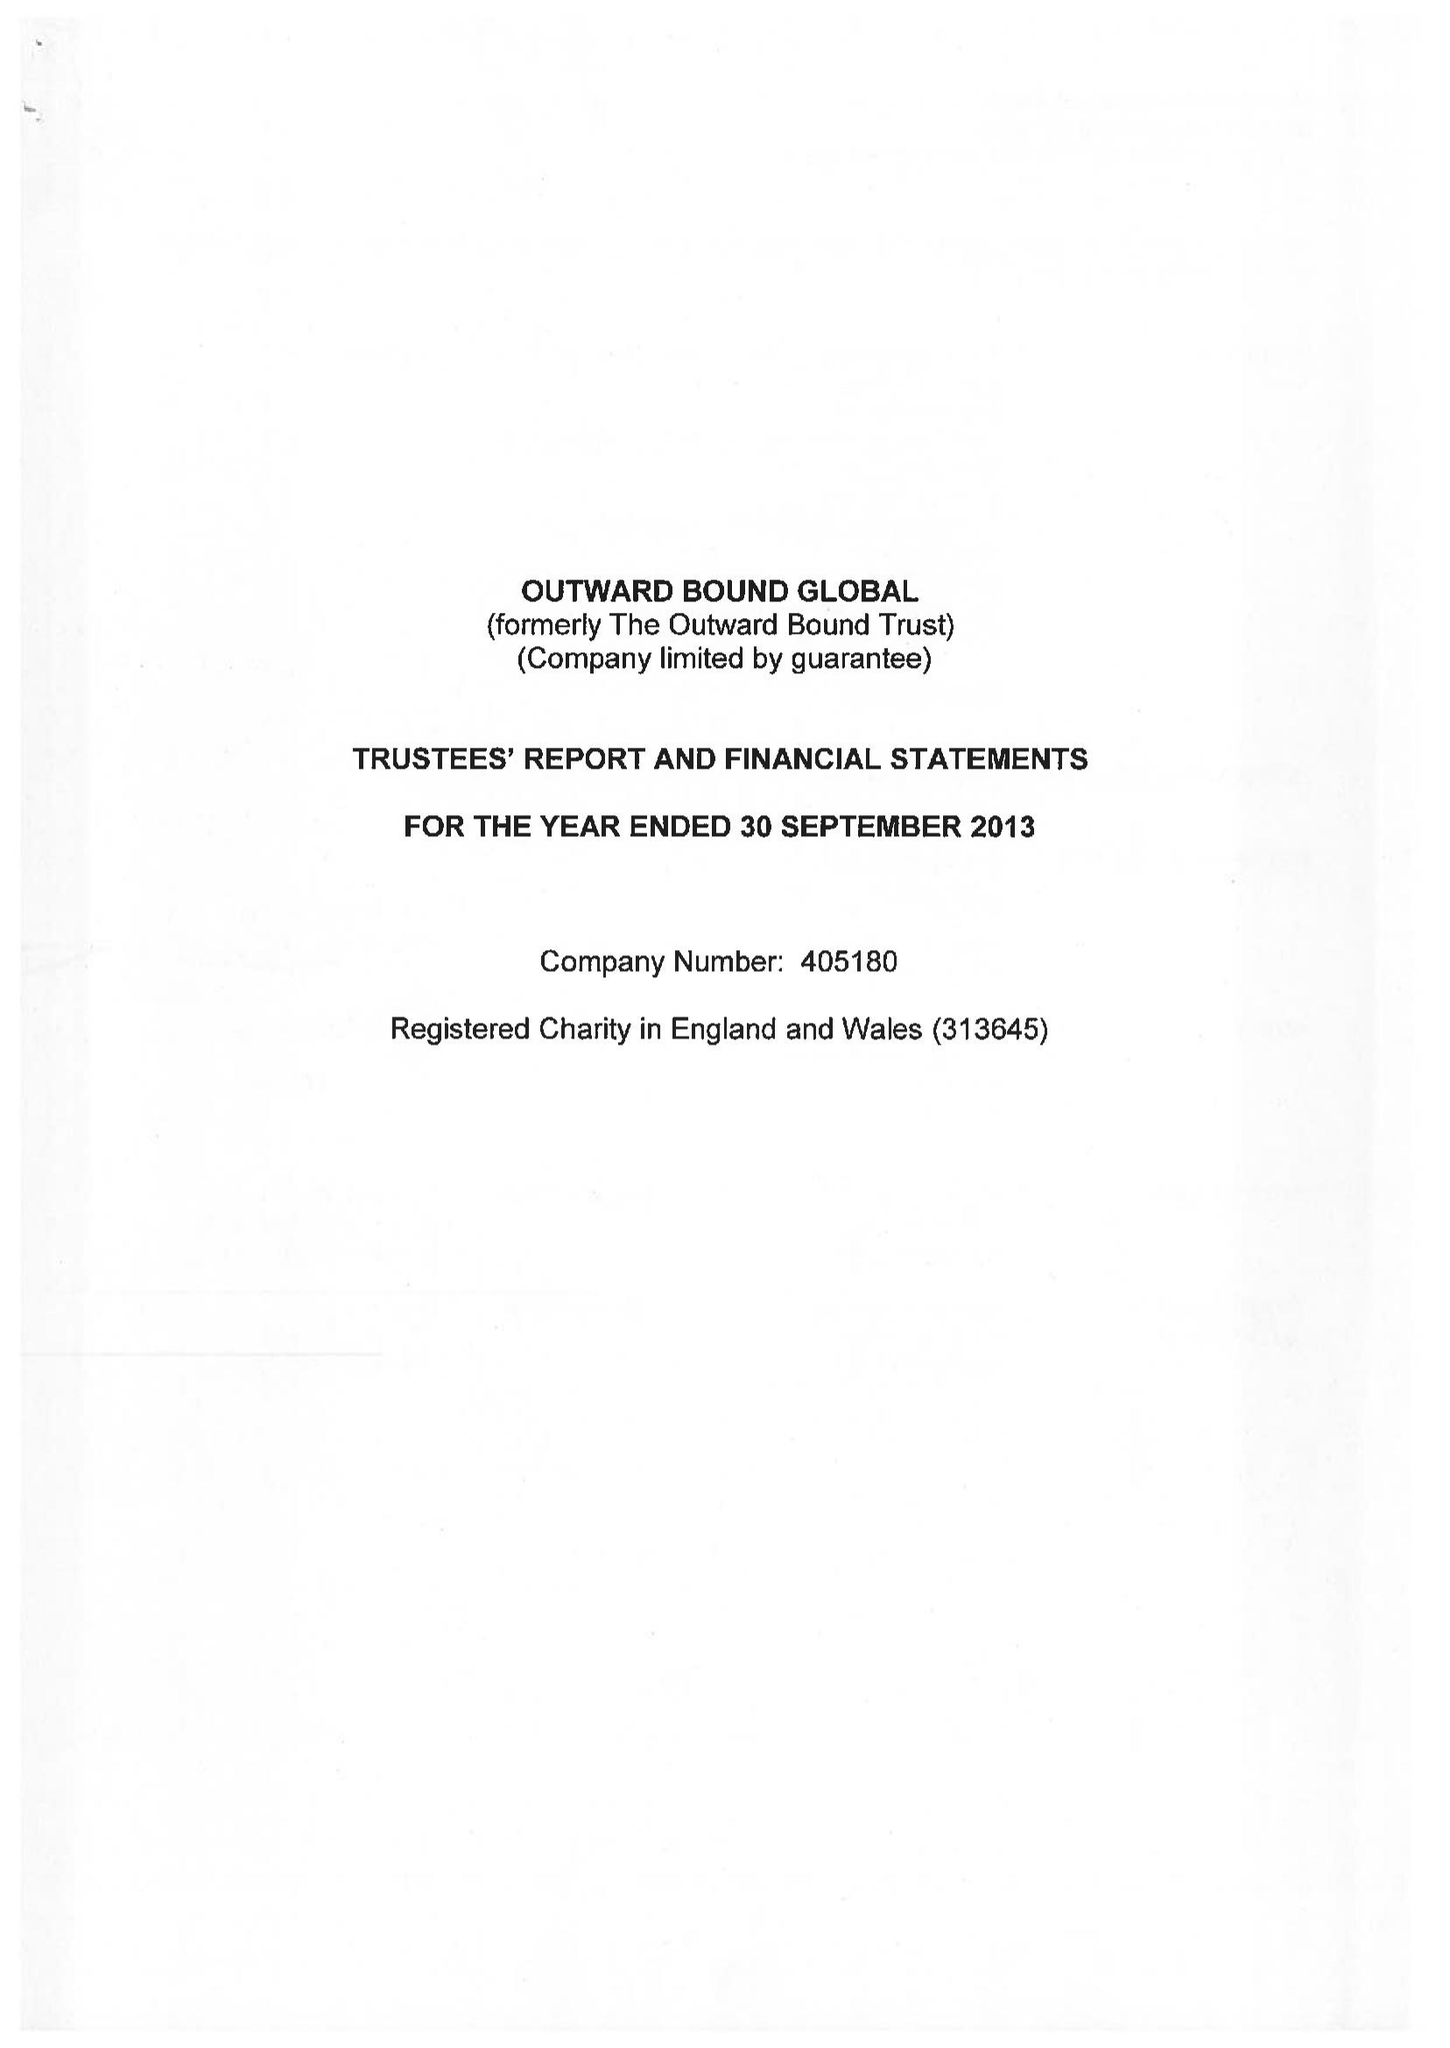What is the value for the spending_annually_in_british_pounds?
Answer the question using a single word or phrase. 505468.00 